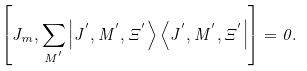<formula> <loc_0><loc_0><loc_500><loc_500>\left [ J _ { m } , \sum _ { M ^ { ^ { \prime } } } \left | J ^ { ^ { \prime } } , M ^ { ^ { \prime } } , \Xi ^ { ^ { \prime } } \right > \left < J ^ { ^ { \prime } } , M ^ { ^ { \prime } } , \Xi ^ { ^ { \prime } } \right | \right ] = 0 .</formula> 